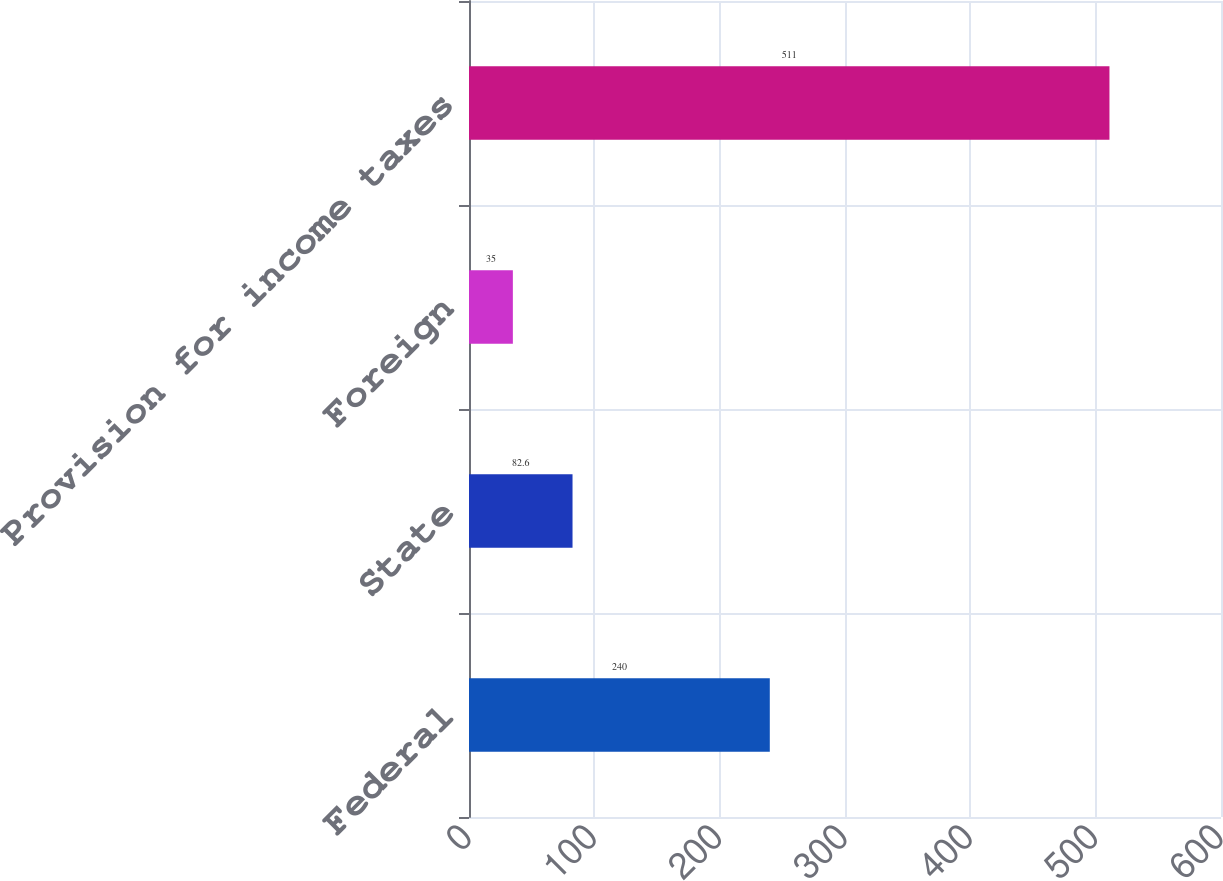Convert chart to OTSL. <chart><loc_0><loc_0><loc_500><loc_500><bar_chart><fcel>Federal<fcel>State<fcel>Foreign<fcel>Provision for income taxes<nl><fcel>240<fcel>82.6<fcel>35<fcel>511<nl></chart> 